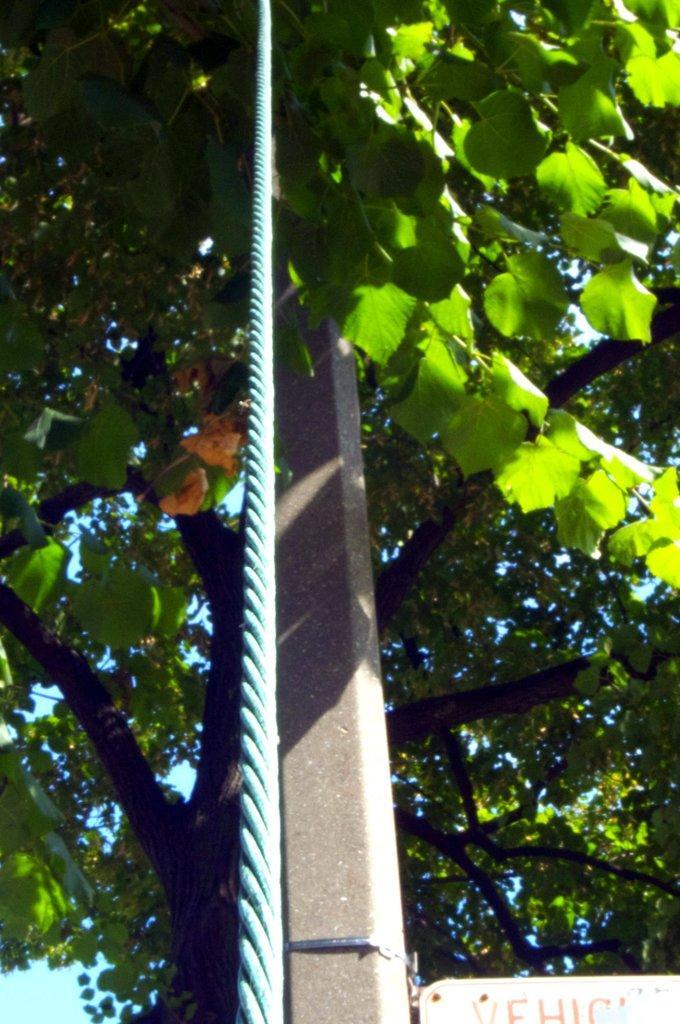Please provide a concise description of this image. This image is taken outdoors. At the right bottom of the image there is a board with a text on it. In the middle of the image there is a pole. There is a rope and there is a tree with leaves, stems and branches. In this image the background is blue in color. 